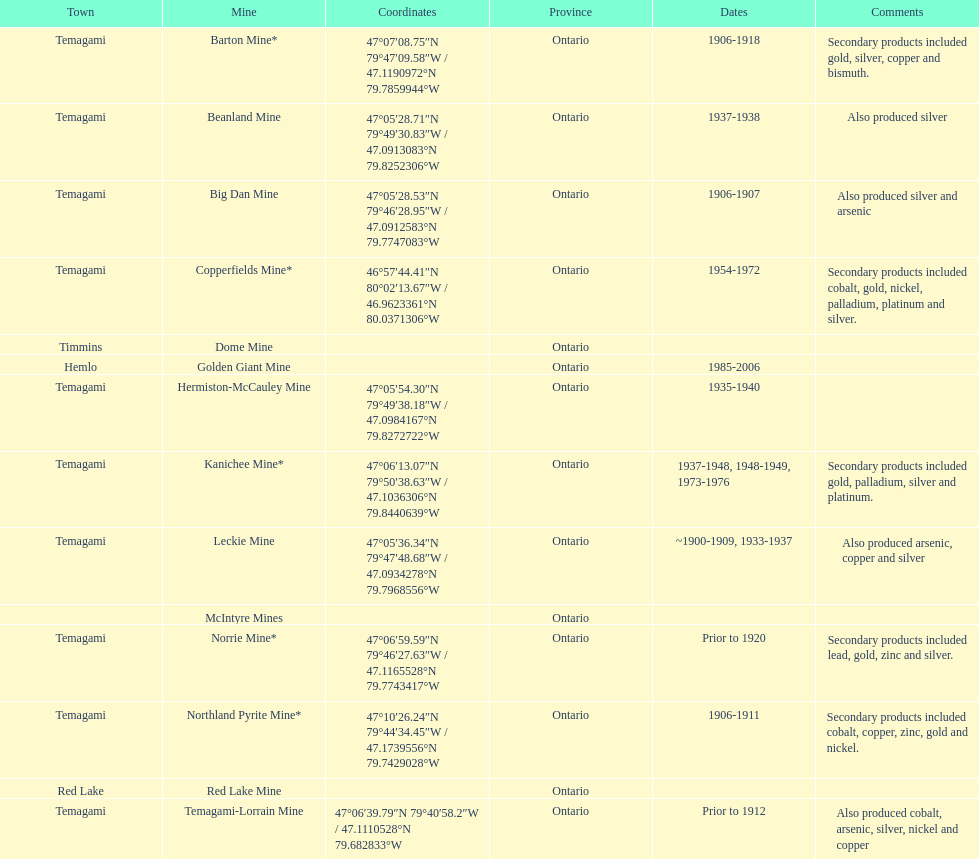How many times is temagami listedon the list? 10. Help me parse the entirety of this table. {'header': ['Town', 'Mine', 'Coordinates', 'Province', 'Dates', 'Comments'], 'rows': [['Temagami', 'Barton Mine*', '47°07′08.75″N 79°47′09.58″W\ufeff / \ufeff47.1190972°N 79.7859944°W', 'Ontario', '1906-1918', 'Secondary products included gold, silver, copper and bismuth.'], ['Temagami', 'Beanland Mine', '47°05′28.71″N 79°49′30.83″W\ufeff / \ufeff47.0913083°N 79.8252306°W', 'Ontario', '1937-1938', 'Also produced silver'], ['Temagami', 'Big Dan Mine', '47°05′28.53″N 79°46′28.95″W\ufeff / \ufeff47.0912583°N 79.7747083°W', 'Ontario', '1906-1907', 'Also produced silver and arsenic'], ['Temagami', 'Copperfields Mine*', '46°57′44.41″N 80°02′13.67″W\ufeff / \ufeff46.9623361°N 80.0371306°W', 'Ontario', '1954-1972', 'Secondary products included cobalt, gold, nickel, palladium, platinum and silver.'], ['Timmins', 'Dome Mine', '', 'Ontario', '', ''], ['Hemlo', 'Golden Giant Mine', '', 'Ontario', '1985-2006', ''], ['Temagami', 'Hermiston-McCauley Mine', '47°05′54.30″N 79°49′38.18″W\ufeff / \ufeff47.0984167°N 79.8272722°W', 'Ontario', '1935-1940', ''], ['Temagami', 'Kanichee Mine*', '47°06′13.07″N 79°50′38.63″W\ufeff / \ufeff47.1036306°N 79.8440639°W', 'Ontario', '1937-1948, 1948-1949, 1973-1976', 'Secondary products included gold, palladium, silver and platinum.'], ['Temagami', 'Leckie Mine', '47°05′36.34″N 79°47′48.68″W\ufeff / \ufeff47.0934278°N 79.7968556°W', 'Ontario', '~1900-1909, 1933-1937', 'Also produced arsenic, copper and silver'], ['', 'McIntyre Mines', '', 'Ontario', '', ''], ['Temagami', 'Norrie Mine*', '47°06′59.59″N 79°46′27.63″W\ufeff / \ufeff47.1165528°N 79.7743417°W', 'Ontario', 'Prior to 1920', 'Secondary products included lead, gold, zinc and silver.'], ['Temagami', 'Northland Pyrite Mine*', '47°10′26.24″N 79°44′34.45″W\ufeff / \ufeff47.1739556°N 79.7429028°W', 'Ontario', '1906-1911', 'Secondary products included cobalt, copper, zinc, gold and nickel.'], ['Red Lake', 'Red Lake Mine', '', 'Ontario', '', ''], ['Temagami', 'Temagami-Lorrain Mine', '47°06′39.79″N 79°40′58.2″W\ufeff / \ufeff47.1110528°N 79.682833°W', 'Ontario', 'Prior to 1912', 'Also produced cobalt, arsenic, silver, nickel and copper']]} 